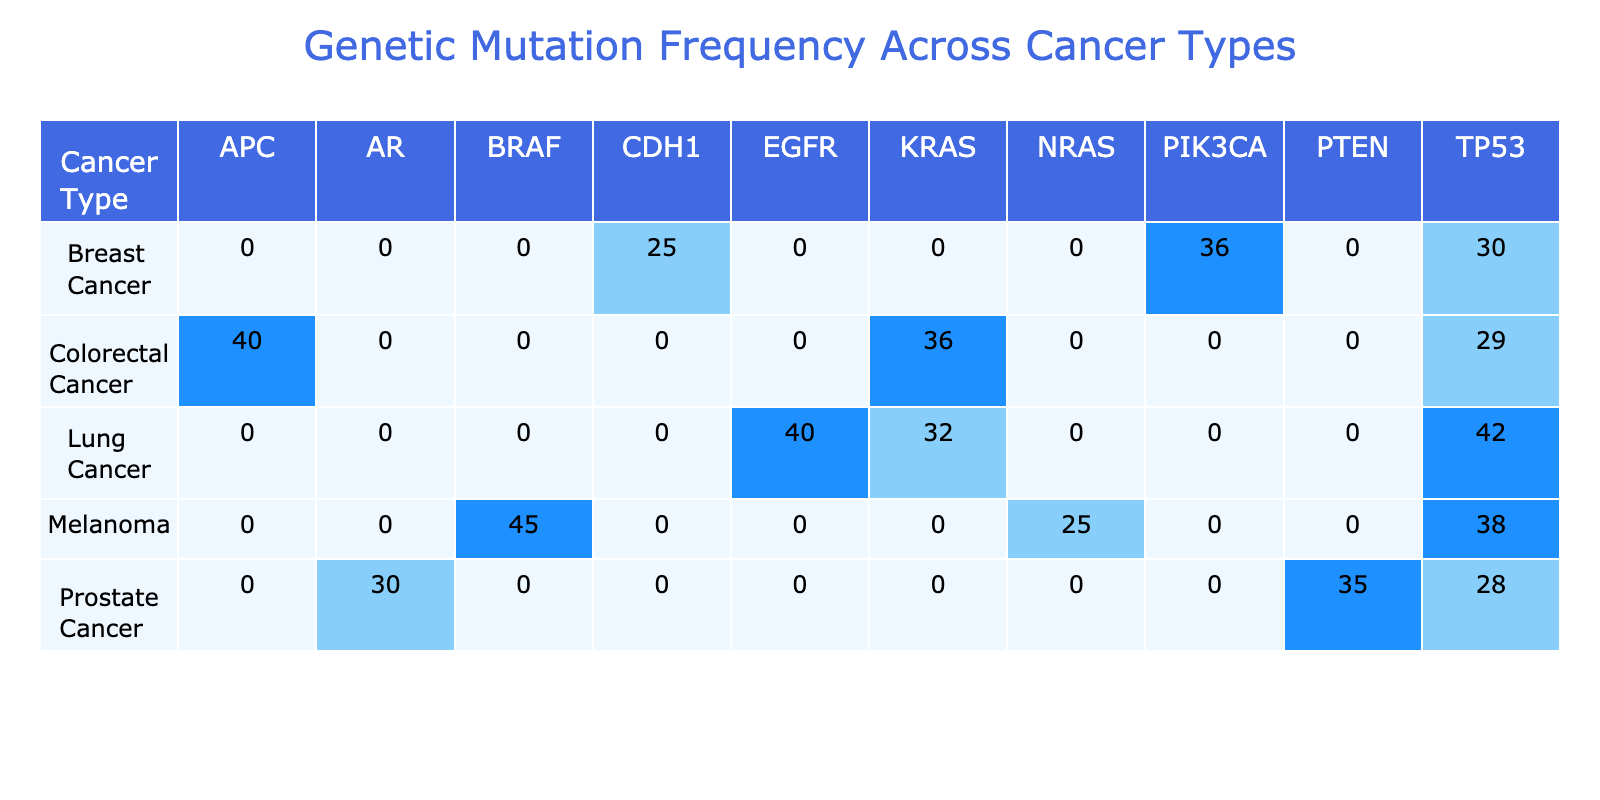What is the frequency of the TP53 mutation in Melanoma? The table shows that the frequency of the TP53 mutation in Melanoma is listed under the "Melanoma" row and the "TP53" column, which is 38.
Answer: 38 Which cancer type has the highest frequency of mutations for PIK3CA? Looking at the table, Breast Cancer has a frequency of 36 for PIK3CA, which is the only entry for that mutation type. Therefore, it is the highest frequency for PIK3CA.
Answer: Breast Cancer What is the total frequency of mutations for Lung Cancer? To calculate the total frequency for Lung Cancer, we sum the frequencies from the relevant row: KRAS (32) + EGFR (40) + TP53 (42) = 114.
Answer: 114 Is the frequency of the mutation AR in Prostate Cancer greater than 30? According to the table, the frequency for AR in Prostate Cancer is listed as 30. Since it's not greater than 30, the answer is no.
Answer: No Which cancer type has the lowest frequency of mutations for CDH1? The only entry for CDH1 is in Breast Cancer, which has a frequency of 25. Since there are no other entries for this mutation, Breast Cancer is the one with the lowest frequency for CDH1.
Answer: Breast Cancer How many mutation types are listed for Colorectal Cancer? In the table under the Colorectal Cancer row, there are three mutation types: APC, TP53, and KRAS. Therefore, the count is three.
Answer: 3 What is the average frequency of the mutations recorded for Breast Cancer? The mutations for Breast Cancer are TP53 (30), PIK3CA (36), and CDH1 (25). Summing these gives 30 + 36 + 25 = 91. To find the average, divide by the number of mutations (3): 91/3 = 30.33.
Answer: 30.33 Is there any cancer type that has a mutation frequency of 45? Looking through the table, Melanoma has a frequency of 45 for BRAF. This indicates that the answer to the question is yes, as it does exist.
Answer: Yes Which mutation type appears most frequently across all cancer types? By analyzing the table, we see the highest frequency is for TP53 (42 in Lung Cancer). Comparing all frequencies, TP53 appears the most frequently across the cancers listed.
Answer: TP53 